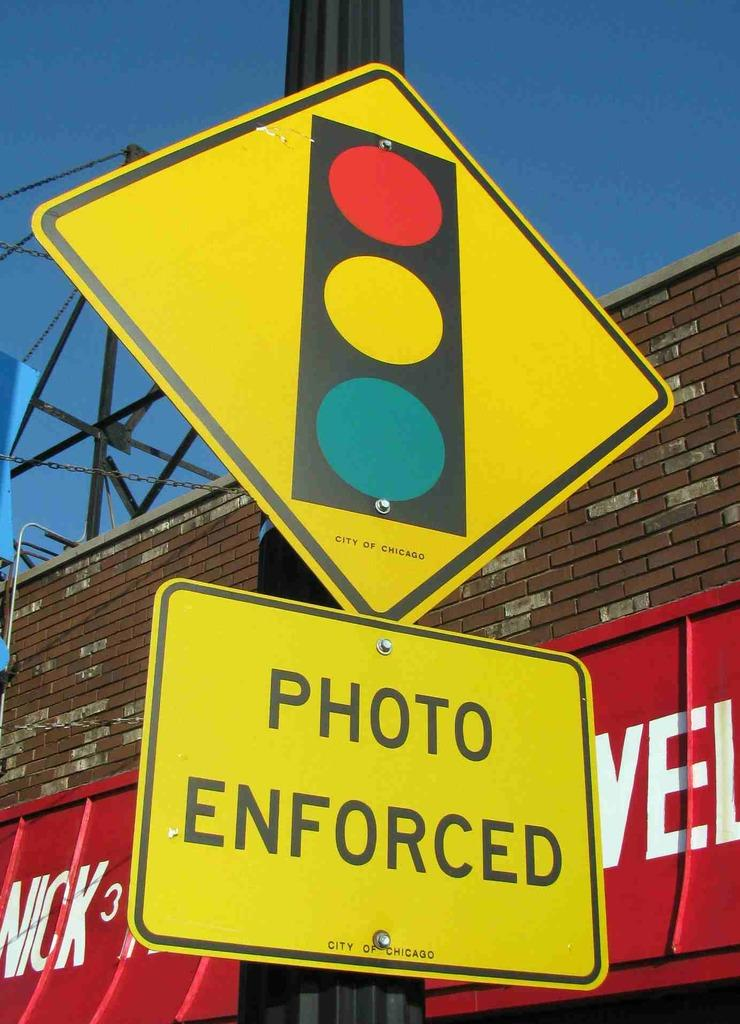<image>
Summarize the visual content of the image. yellow street sign with the words photo enforced 